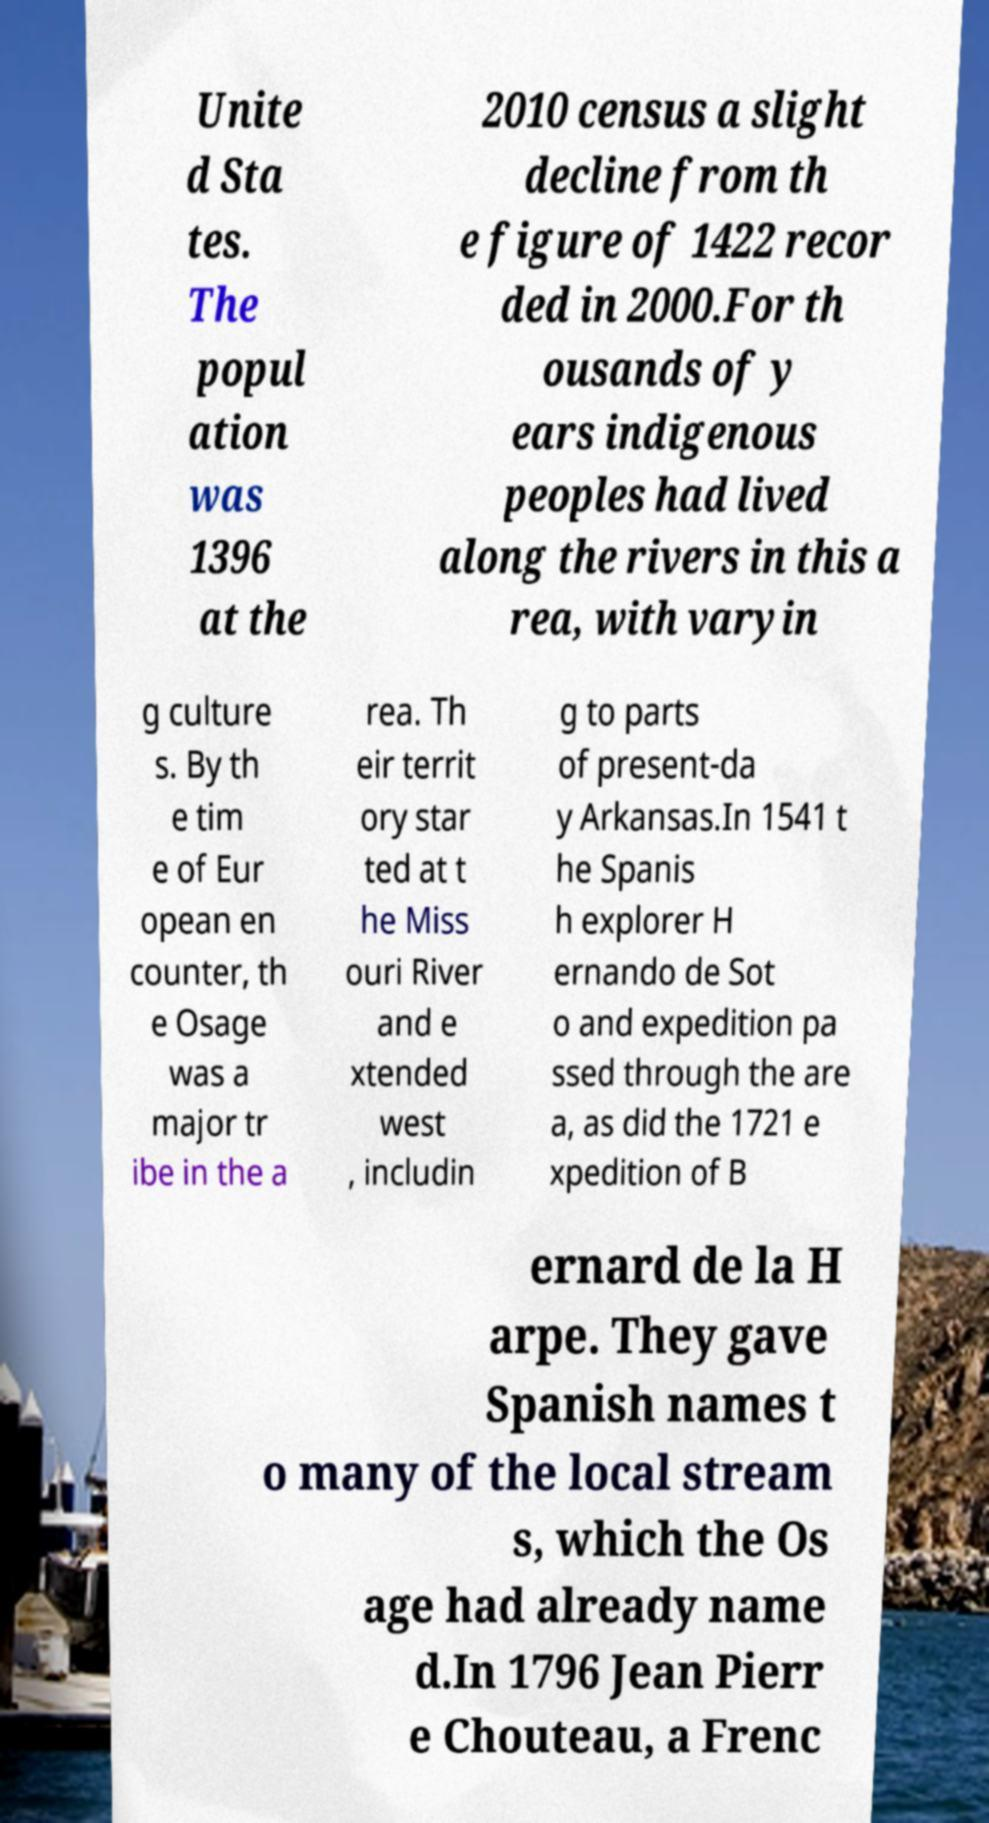Could you extract and type out the text from this image? Unite d Sta tes. The popul ation was 1396 at the 2010 census a slight decline from th e figure of 1422 recor ded in 2000.For th ousands of y ears indigenous peoples had lived along the rivers in this a rea, with varyin g culture s. By th e tim e of Eur opean en counter, th e Osage was a major tr ibe in the a rea. Th eir territ ory star ted at t he Miss ouri River and e xtended west , includin g to parts of present-da y Arkansas.In 1541 t he Spanis h explorer H ernando de Sot o and expedition pa ssed through the are a, as did the 1721 e xpedition of B ernard de la H arpe. They gave Spanish names t o many of the local stream s, which the Os age had already name d.In 1796 Jean Pierr e Chouteau, a Frenc 